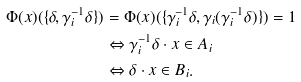Convert formula to latex. <formula><loc_0><loc_0><loc_500><loc_500>\Phi ( x ) ( \{ \delta , \gamma ^ { - 1 } _ { i } \delta \} ) & = \Phi ( x ) ( \{ \gamma ^ { - 1 } _ { i } \delta , \gamma _ { i } ( \gamma ^ { - 1 } _ { i } \delta ) \} ) = 1 \\ & \Leftrightarrow \gamma ^ { - 1 } _ { i } \delta \cdot x \in A _ { i } \\ & \Leftrightarrow \delta \cdot x \in B _ { i } .</formula> 